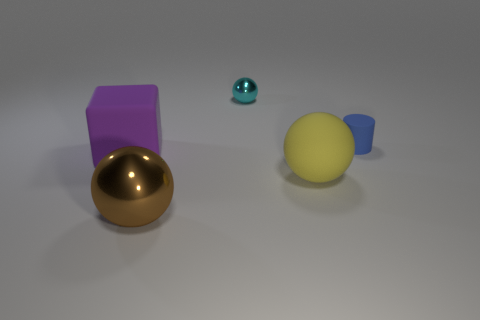There is a matte thing that is both behind the yellow sphere and on the right side of the big brown shiny sphere; what shape is it?
Provide a succinct answer. Cylinder. What number of other things are there of the same shape as the small blue thing?
Offer a very short reply. 0. There is a metal object behind the large rubber thing that is right of the metallic sphere that is to the left of the tiny cyan metal sphere; what is its shape?
Provide a short and direct response. Sphere. What number of things are blue shiny blocks or large balls in front of the yellow matte object?
Offer a terse response. 1. There is a object that is behind the blue matte thing; is its shape the same as the big rubber thing that is on the right side of the big purple cube?
Provide a short and direct response. Yes. How many objects are brown metal balls or large green shiny things?
Offer a very short reply. 1. Is there a blue metal object?
Your answer should be very brief. No. Does the thing that is behind the blue rubber thing have the same material as the blue thing?
Give a very brief answer. No. Are there any tiny cyan metallic objects of the same shape as the brown metallic object?
Your answer should be compact. Yes. Are there the same number of cubes that are to the right of the big purple object and yellow balls?
Your response must be concise. No. 